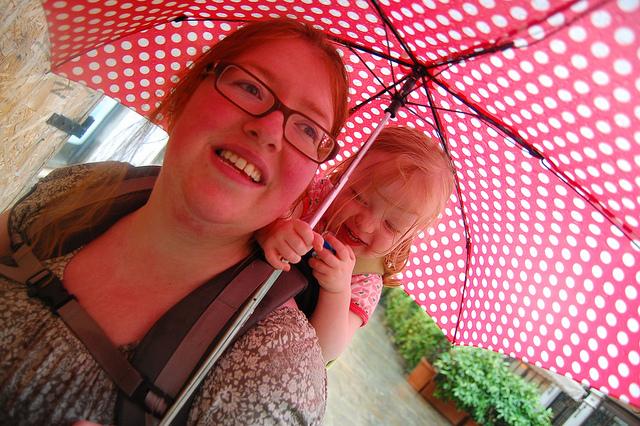Who is holding the umbrella?
Write a very short answer. Child. What is the design on the umbrella?
Answer briefly. Polka dots. How many people are shown?
Answer briefly. 2. 